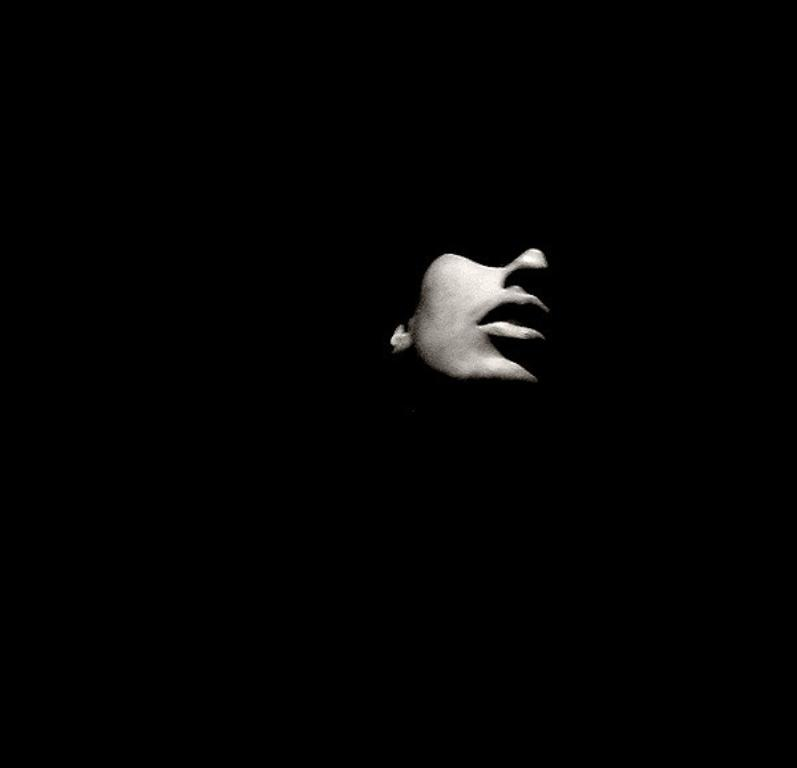What is depicted in the center of the image? There is a drawing of a bird in the center of the image. Can you describe the main subject of the image? The main subject of the image is a drawing of a bird. How many balls are visible in the image? There are no balls present in the image; it features a drawing of a bird. What is the distance between the bird and the edge of the image? The distance between the bird and the edge of the image cannot be determined from the image alone, as it only shows the bird in the center. 